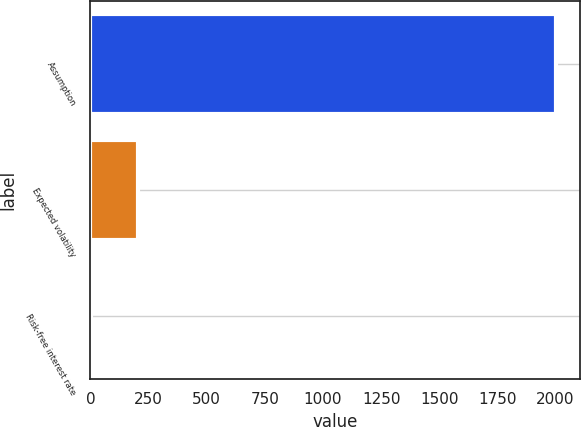Convert chart to OTSL. <chart><loc_0><loc_0><loc_500><loc_500><bar_chart><fcel>Assumption<fcel>Expected volatility<fcel>Risk-free interest rate<nl><fcel>2003<fcel>202.92<fcel>2.91<nl></chart> 